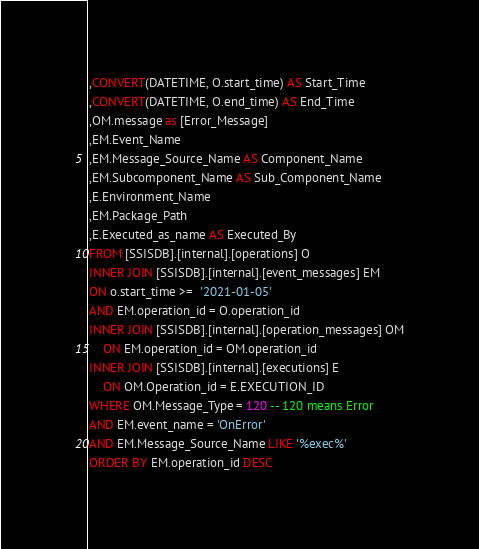Convert code to text. <code><loc_0><loc_0><loc_500><loc_500><_SQL_>,CONVERT(DATETIME, O.start_time) AS Start_Time 
,CONVERT(DATETIME, O.end_time) AS End_Time 
,OM.message as [Error_Message] 
,EM.Event_Name 
,EM.Message_Source_Name AS Component_Name 
,EM.Subcomponent_Name AS Sub_Component_Name 
,E.Environment_Name 
,EM.Package_Path 
,E.Executed_as_name AS Executed_By 
FROM [SSISDB].[internal].[operations] O 
INNER JOIN [SSISDB].[internal].[event_messages] EM 
ON o.start_time >=  '2021-01-05'
AND EM.operation_id = O.operation_id 
INNER JOIN [SSISDB].[internal].[operation_messages] OM
	ON EM.operation_id = OM.operation_id 
INNER JOIN [SSISDB].[internal].[executions] E 
	ON OM.Operation_id = E.EXECUTION_ID 
WHERE OM.Message_Type = 120 -- 120 means Error 
AND EM.event_name = 'OnError' 
AND EM.Message_Source_Name LIKE '%exec%'
ORDER BY EM.operation_id DESC</code> 